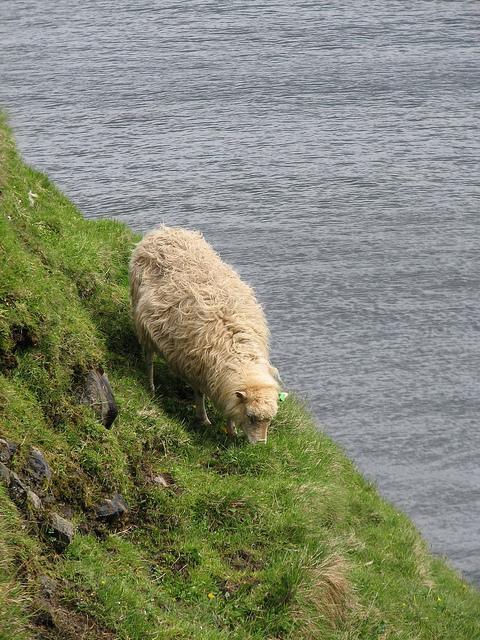How many legs does the animal have?
Give a very brief answer. 4. 